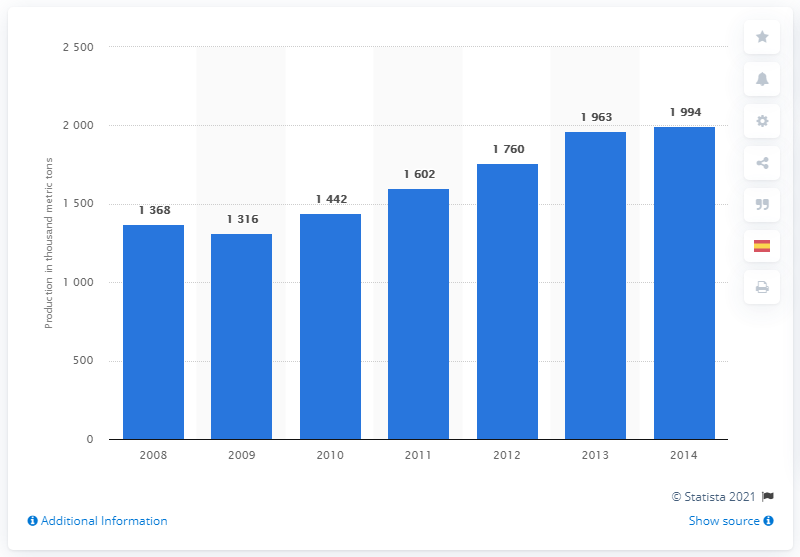Mention a couple of crucial points in this snapshot. The global primary production volumes for nickel were last reported in 2014. 